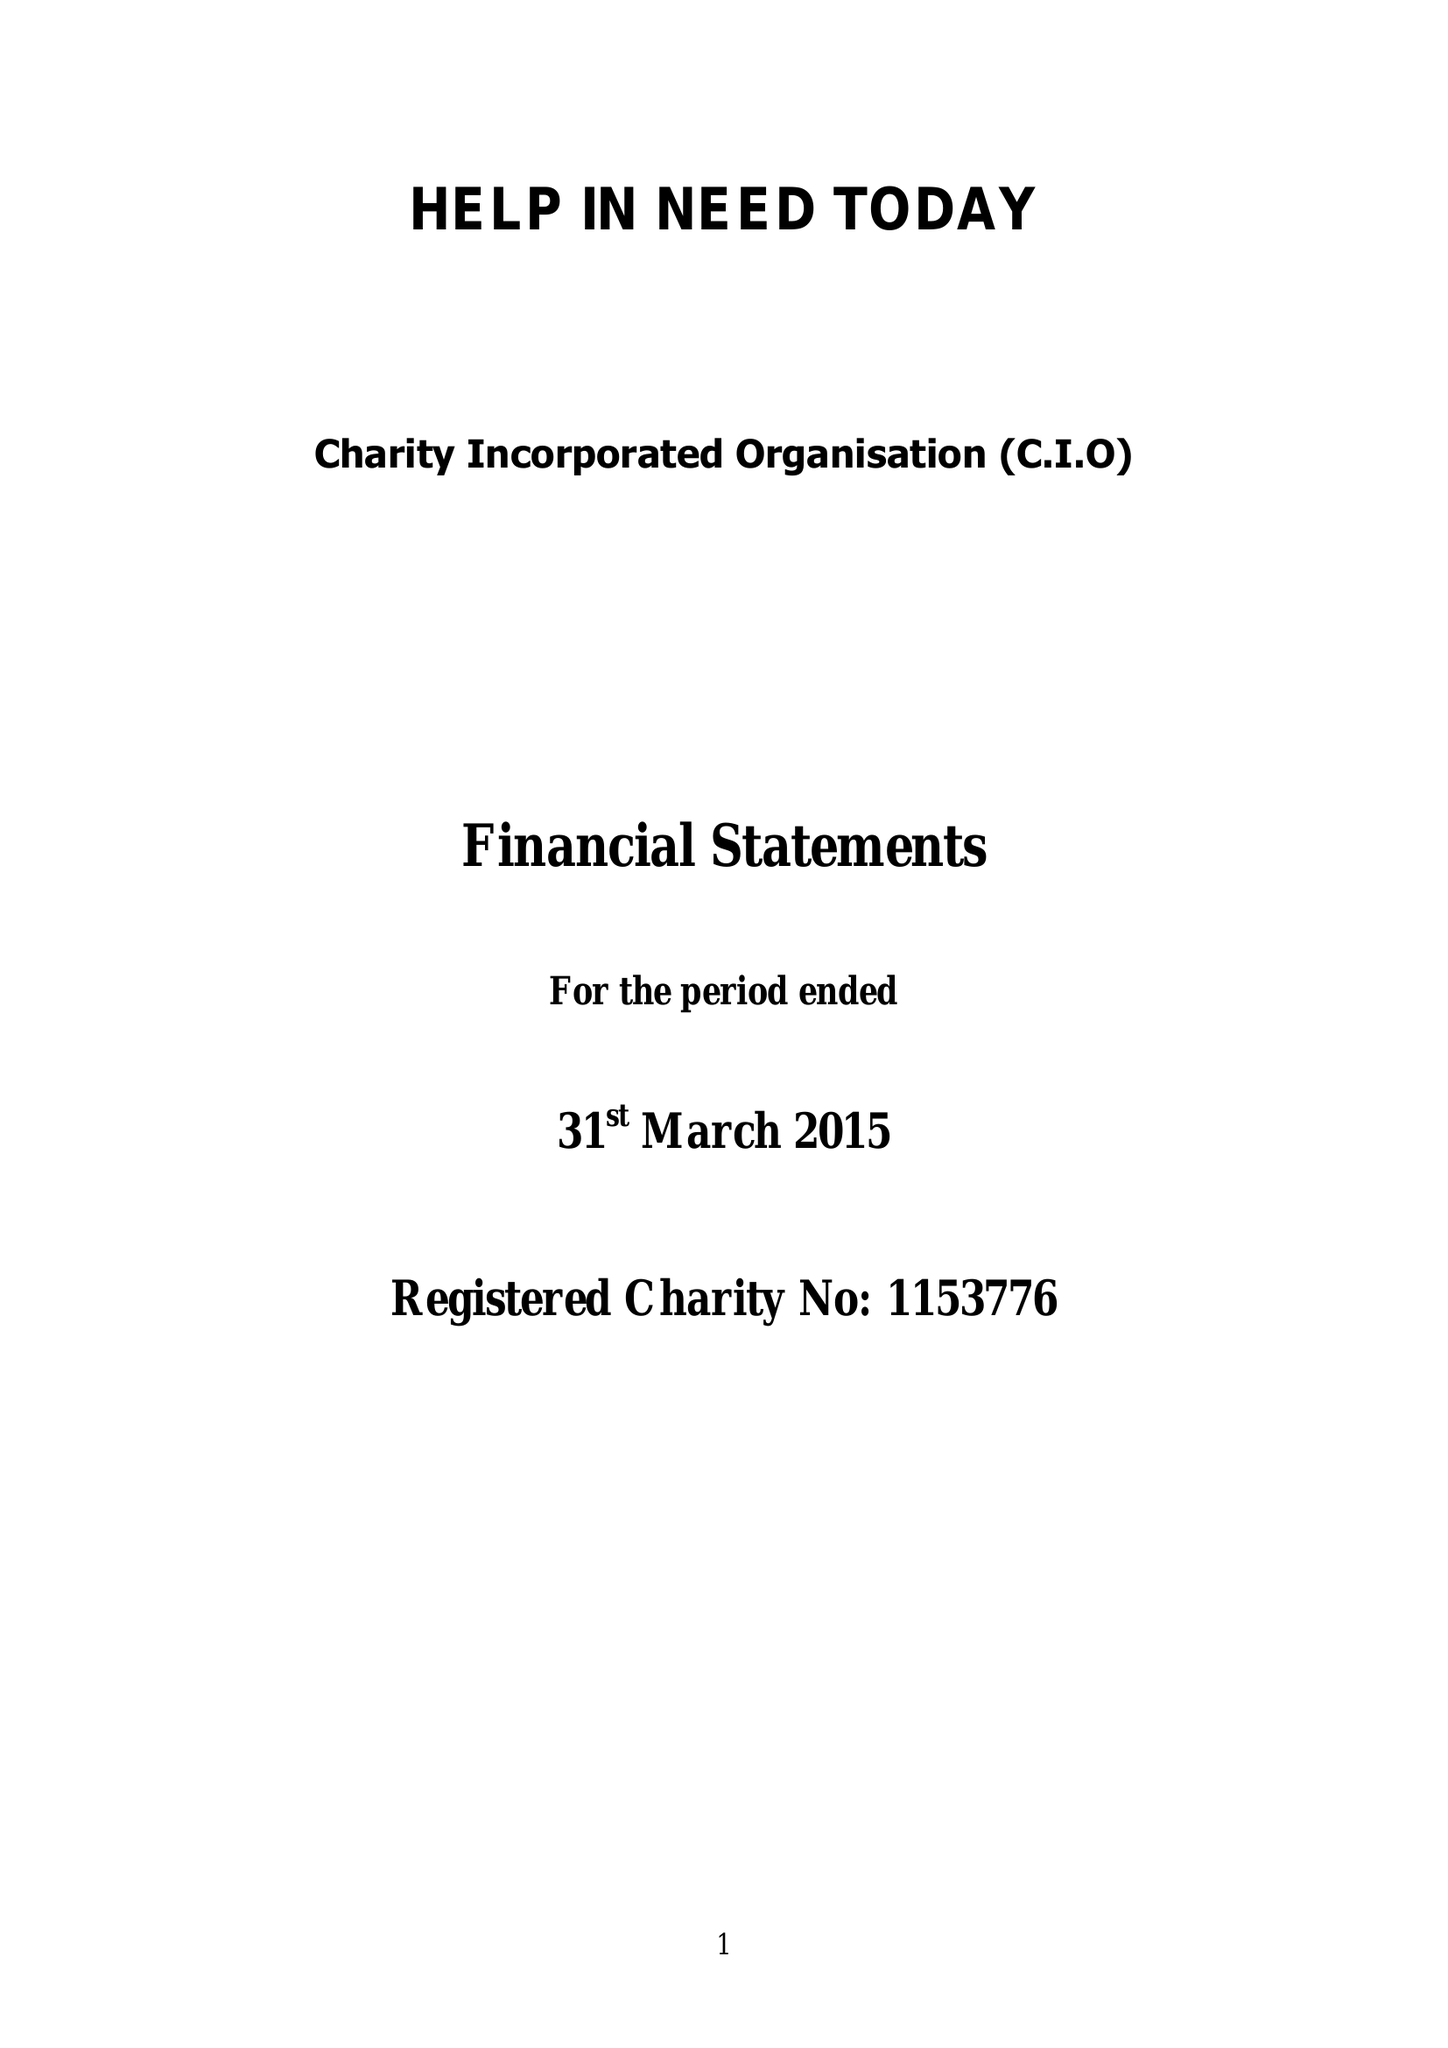What is the value for the address__street_line?
Answer the question using a single word or phrase. 37 MADEIRA ROAD 